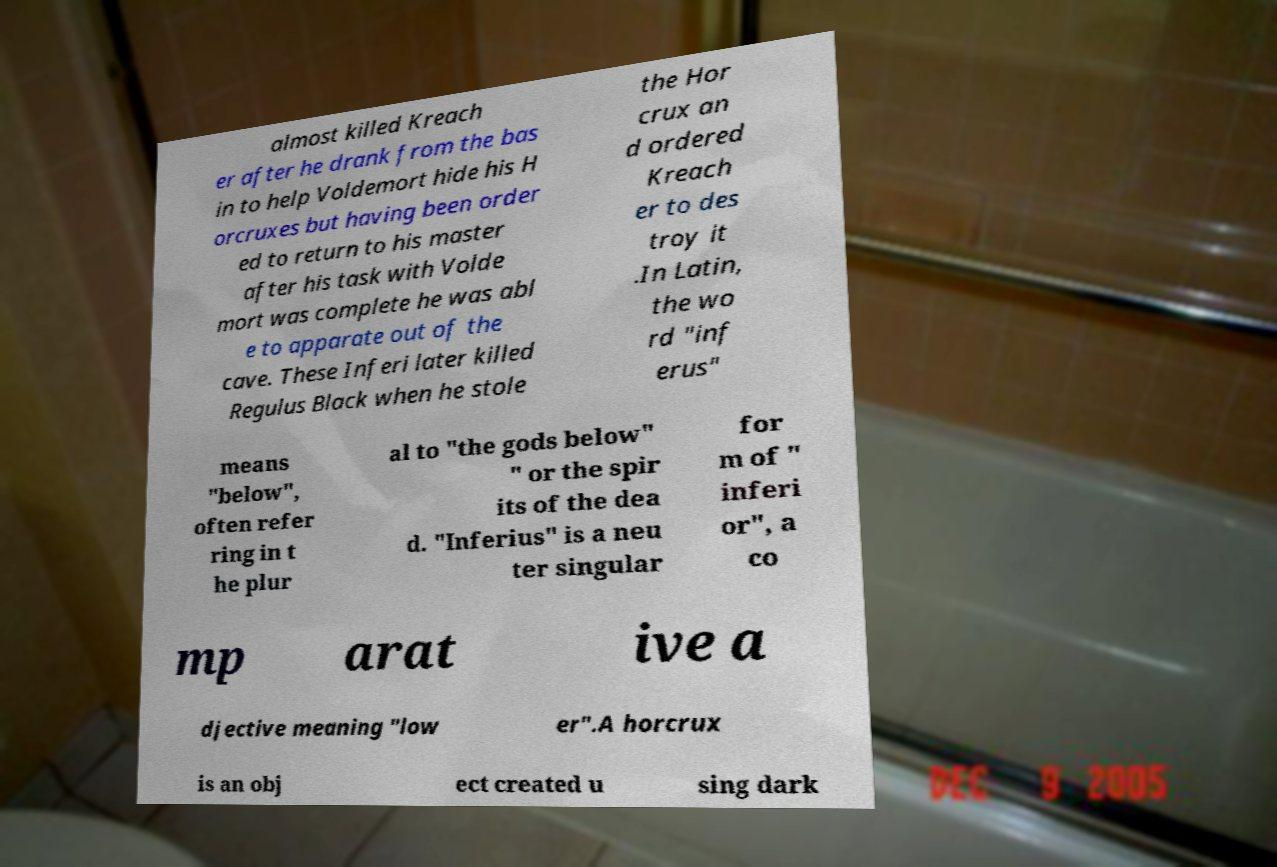Please identify and transcribe the text found in this image. almost killed Kreach er after he drank from the bas in to help Voldemort hide his H orcruxes but having been order ed to return to his master after his task with Volde mort was complete he was abl e to apparate out of the cave. These Inferi later killed Regulus Black when he stole the Hor crux an d ordered Kreach er to des troy it .In Latin, the wo rd "inf erus" means "below", often refer ring in t he plur al to "the gods below" " or the spir its of the dea d. "Inferius" is a neu ter singular for m of " inferi or", a co mp arat ive a djective meaning "low er".A horcrux is an obj ect created u sing dark 